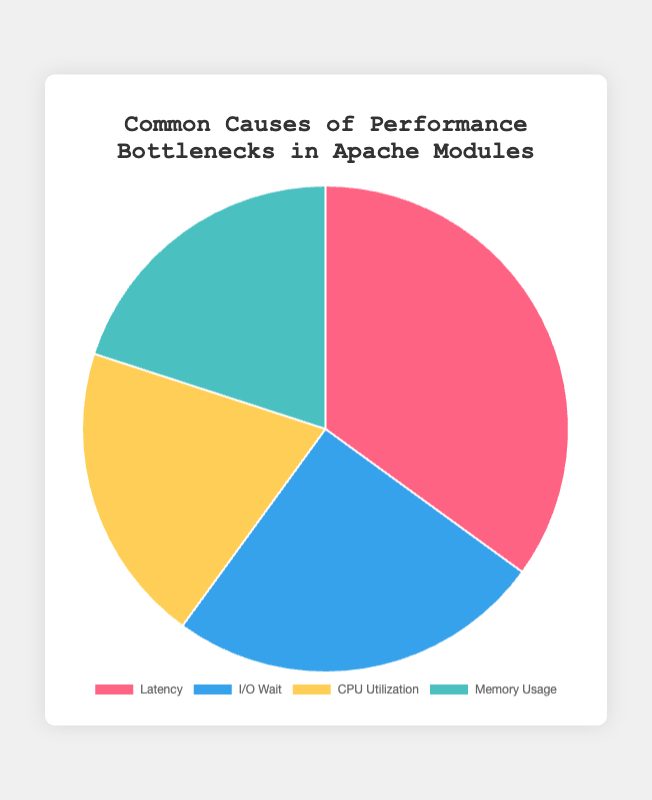What is the most common cause of performance bottlenecks in Apache modules? According to the pie chart, Latency holds the largest percentage at 35%, making it the most common cause.
Answer: Latency Which performance bottleneck has the smallest percentage? Both CPU Utilization and Memory Usage have the smallest percentage, each representing 20% of the total causes.
Answer: CPU Utilization and Memory Usage How much more common is Latency compared to I/O Wait? Latency accounts for 35% and I/O Wait for 25%. The difference is 35% - 25% = 10%.
Answer: 10% What is the sum of the percentages of CPU Utilization and Memory Usage? CPU Utilization is 20% and Memory Usage is 20%. Their sum is 20% + 20% = 40%.
Answer: 40% What percentage of the performance bottlenecks are due to factors other than Latency? Latency accounts for 35%, so the remaining percentage is 100% - 35% = 65%.
Answer: 65% Which cause has the highest representation and which has the lowest? The highest is Latency at 35% and the lowest are both CPU Utilization and Memory Usage at 20%.
Answer: Highest: Latency, Lowest: CPU Utilization and Memory Usage Are there any causes that have equal representation in the performance bottlenecks? Yes, CPU Utilization and Memory Usage both have equal representation, each with 20%.
Answer: Yes What is the combined percentage of Latency and I/O Wait? Latency accounts for 35% and I/O Wait for 25%. Their combined percentage is 35% + 25% = 60%.
Answer: 60% Describe the color associated with the cause that has the second highest percentage. The second highest percentage is I/O Wait at 25%. According to the color scheme, it is represented in blue.
Answer: Blue 